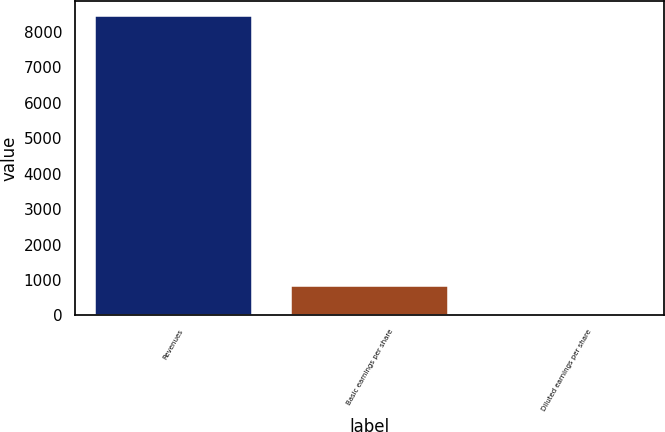<chart> <loc_0><loc_0><loc_500><loc_500><bar_chart><fcel>Revenues<fcel>Basic earnings per share<fcel>Diluted earnings per share<nl><fcel>8434<fcel>844.01<fcel>0.68<nl></chart> 